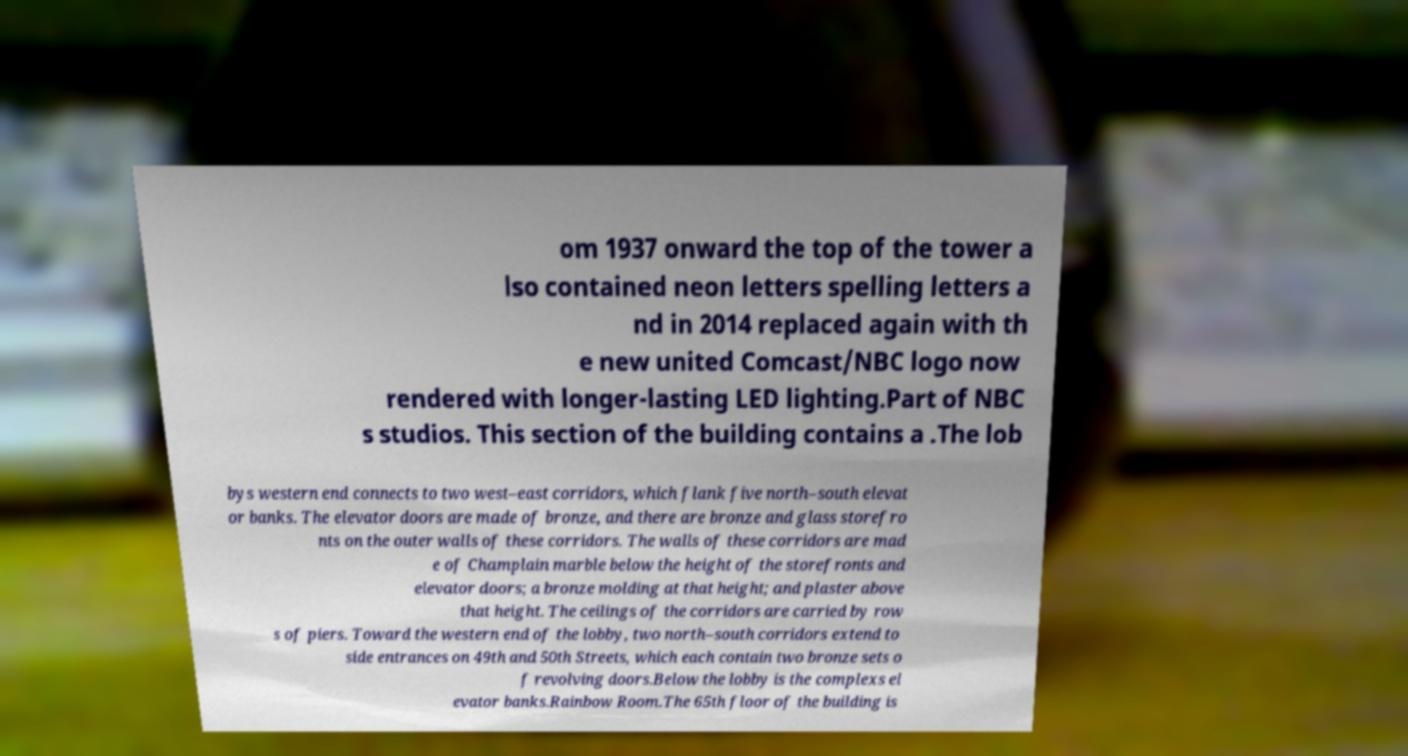Can you read and provide the text displayed in the image?This photo seems to have some interesting text. Can you extract and type it out for me? om 1937 onward the top of the tower a lso contained neon letters spelling letters a nd in 2014 replaced again with th e new united Comcast/NBC logo now rendered with longer-lasting LED lighting.Part of NBC s studios. This section of the building contains a .The lob bys western end connects to two west–east corridors, which flank five north–south elevat or banks. The elevator doors are made of bronze, and there are bronze and glass storefro nts on the outer walls of these corridors. The walls of these corridors are mad e of Champlain marble below the height of the storefronts and elevator doors; a bronze molding at that height; and plaster above that height. The ceilings of the corridors are carried by row s of piers. Toward the western end of the lobby, two north–south corridors extend to side entrances on 49th and 50th Streets, which each contain two bronze sets o f revolving doors.Below the lobby is the complexs el evator banks.Rainbow Room.The 65th floor of the building is 